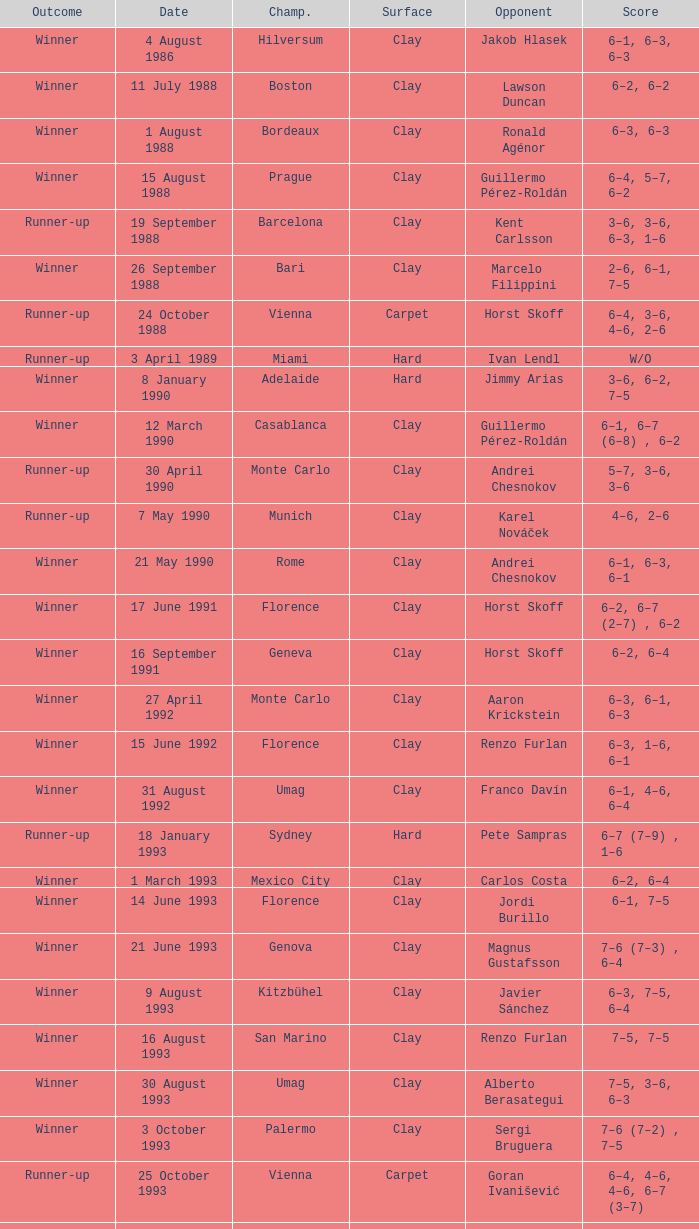Who is the opponent when the surface is clay, the outcome is winner and the championship is estoril on 15 april 1996? Andrea Gaudenzi. 